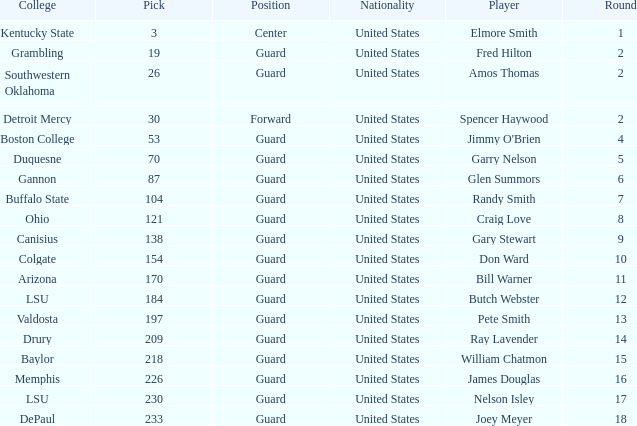WHAT COLLEGE HAS A ROUND LARGER THAN 9, WITH BUTCH WEBSTER? LSU. 